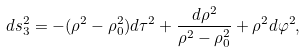Convert formula to latex. <formula><loc_0><loc_0><loc_500><loc_500>d s ^ { 2 } _ { 3 } = - ( \rho ^ { 2 } - \rho _ { 0 } ^ { 2 } ) d \tau ^ { 2 } + \frac { d \rho ^ { 2 } } { \rho ^ { 2 } - \rho _ { 0 } ^ { 2 } } + \rho ^ { 2 } d \varphi ^ { 2 } ,</formula> 